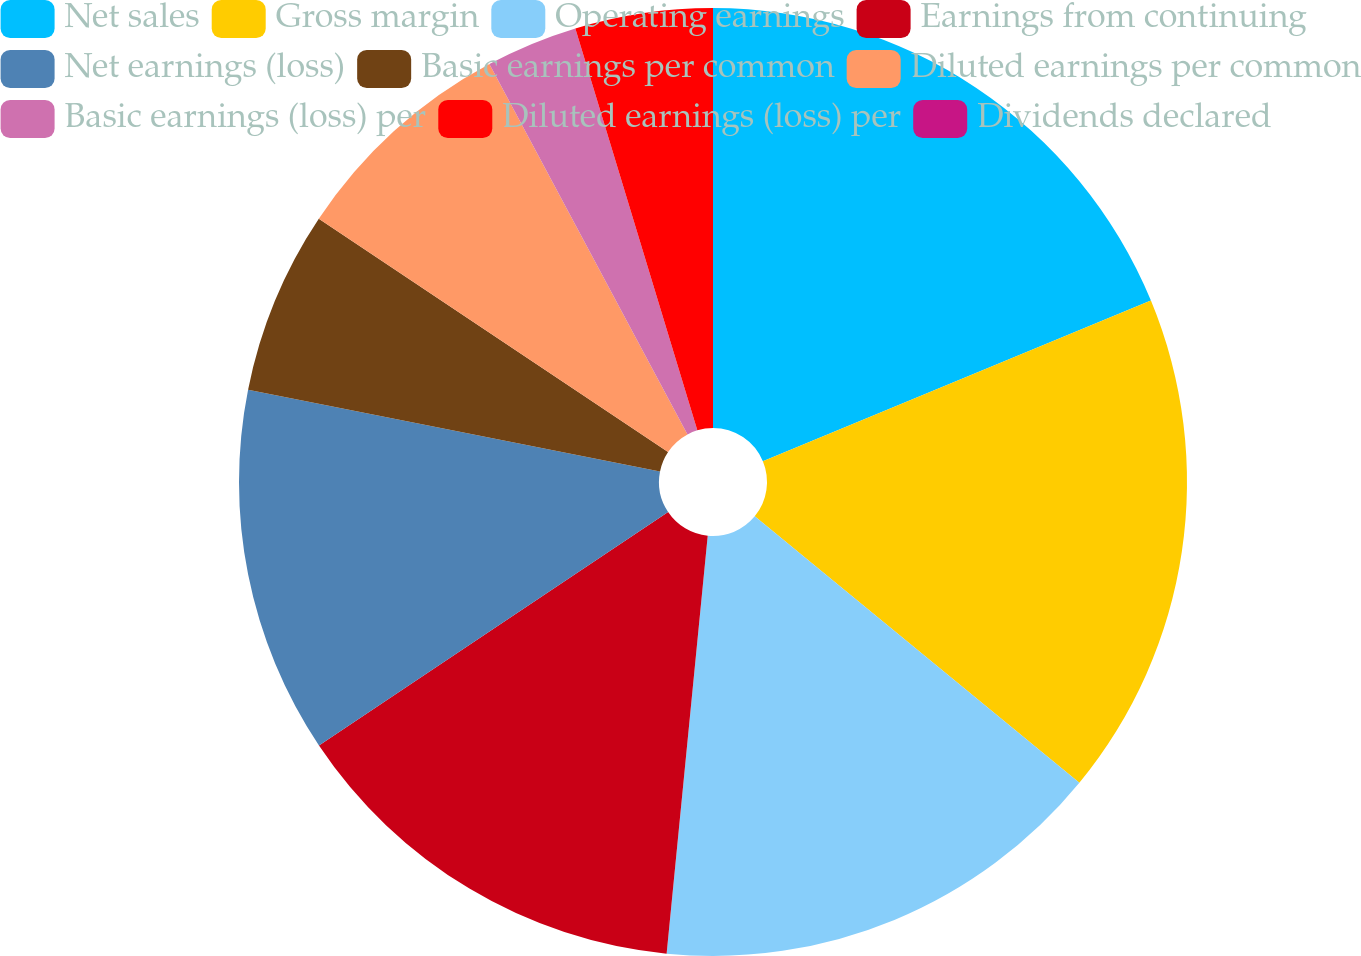Convert chart to OTSL. <chart><loc_0><loc_0><loc_500><loc_500><pie_chart><fcel>Net sales<fcel>Gross margin<fcel>Operating earnings<fcel>Earnings from continuing<fcel>Net earnings (loss)<fcel>Basic earnings per common<fcel>Diluted earnings per common<fcel>Basic earnings (loss) per<fcel>Diluted earnings (loss) per<fcel>Dividends declared<nl><fcel>18.75%<fcel>17.19%<fcel>15.62%<fcel>14.06%<fcel>12.5%<fcel>6.25%<fcel>7.81%<fcel>3.13%<fcel>4.69%<fcel>0.0%<nl></chart> 